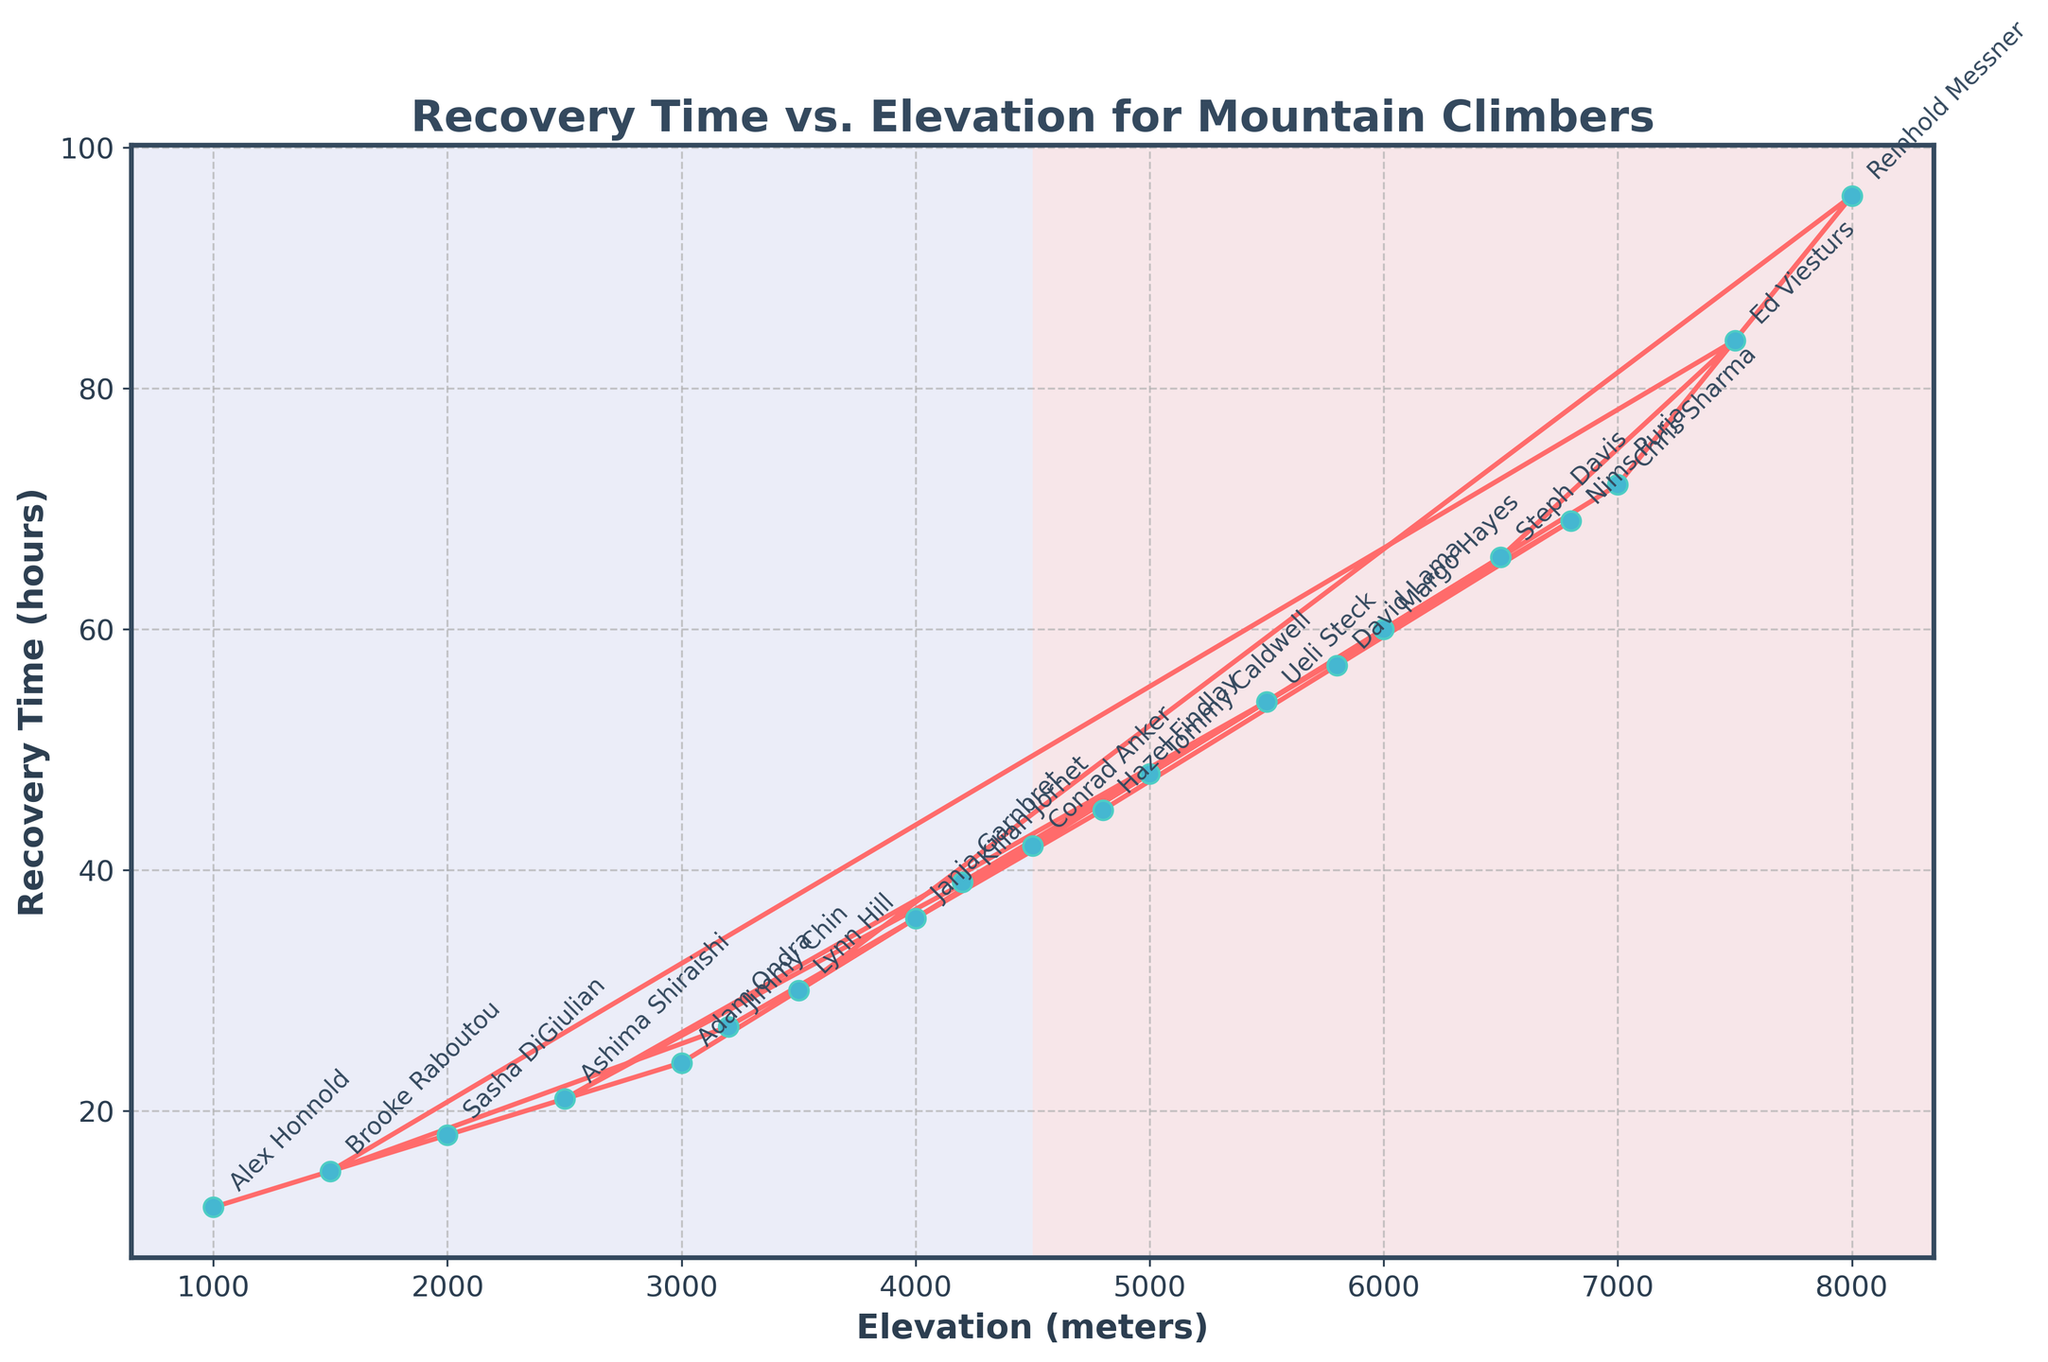What's the recovery time for the climber at 3000 meters? Look at the data point corresponding to 3000 meters on the x-axis and find the y-axis value. According to the figure, Adam Ondra has a recovery time of 24 hours.
Answer: 24 hours Which climber has the longest recovery time? Find the highest point on the y-axis and refer to the climber name annotated at that position on the chart. The highest recovery time is 96 hours at 8000 meters, which belongs to Reinhold Messner.
Answer: Reinhold Messner What is the difference in recovery time between the highest and lowest elevations? Locate the recovery times for the highest (8000 meters = 96 hours) and lowest (1000 meters = 12 hours) elevations, then subtract the lowest from the highest. So, 96 - 12 = 84 hours.
Answer: 84 hours Between which two consecutive elevations do we see the largest increase in recovery time? Look at the differences in recovery times between successive data points and find the largest gap. The largest increase is between 7000 meters (72 hours) and 8000 meters (96 hours), with a difference of 24 hours.
Answer: Between 7000 and 8000 meters What is the average recovery time of climbers at elevations over 5000 meters? Identify the recovery times for elevations over 5000 meters (54, 57, 60, 66, 69, 72, 84, 96 hours) and calculate the average: (54 + 57 + 60 + 66 + 69 + 72 + 84 + 96) / 8 = 69.75 hours.
Answer: 69.75 hours Who is the climber at 4200 meters, and what is their recovery time? Locate the data point for 4200 meters, find the annotative text for the climber's name, and check the recovery time. Kilian Jornet is at 4200 meters with a recovery time of 39 hours.
Answer: Kilian Jornet, 39 hours Does the recovery time generally increase, decrease, or stay the same as elevation increases? Observe the trend line of the plot, which generally moves upwards as the x-axis (elevation) increases, indicating an increase in recovery time.
Answer: Increase Among all climbers, who has a recovery time of 45 hours and at what elevation? Locate the data point at 45 hours on the y-axis and read the x-axis value and name annotation. Hazel Findlay has a recovery time of 45 hours at 4800 meters.
Answer: Hazel Findlay, 4800 meters How much more recovery time does a climber need at 6000 meters compared to a climber at 3200 meters? Identify the recovery times at 6000 meters (60 hours) and 3200 meters (27 hours) and subtract the latter from the former. So, 60 - 27 = 33 hours.
Answer: 33 hours Which climber shows the closest recovery time to the average recovery time across all elevations? Calculate the average recovery time across all data points, find the recovery times (in hours) of each climber, and check the closest value. The average is approximately 43.6 hours, and Conrad Anker, with 42 hours at 4500 meters, is the closest.
Answer: Conrad Anker 